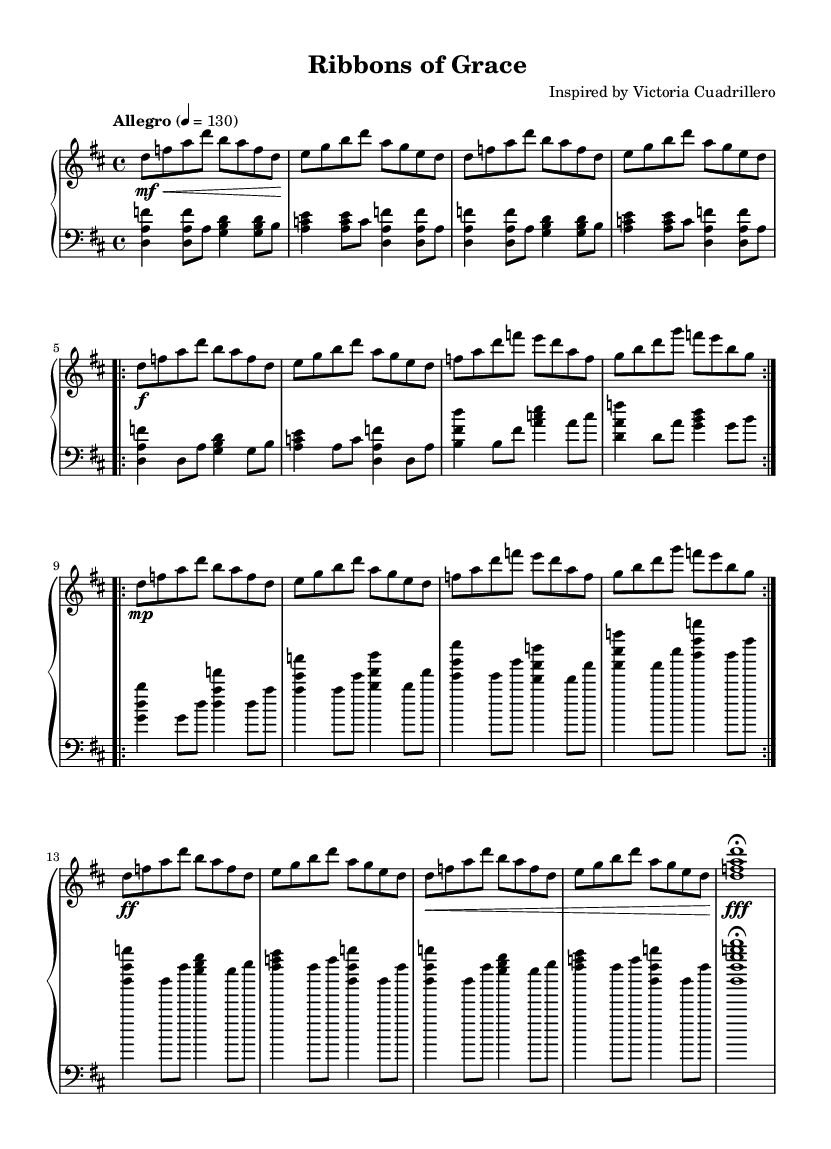What is the key signature of this music? The key signature can be determined by identifying the sharps or flats indicated at the beginning of the piece. In this case, there are two sharps, F# and C#, which corresponds to the D major key signature.
Answer: D major What is the time signature of this music? The time signature is located at the beginning of the sheet music, which shows the division of beats in each measure. Here, the notation "4/4" indicates that there are four beats per measure, and the quarter note is one beat.
Answer: 4/4 What is the tempo marking of the piece? The tempo is indicated by the instruction "Allegro" followed by a metronome marking of 4 = 130. This suggests a fast pace, typically around 120-168 beats per minute.
Answer: Allegro, 130 What is the musical form of this piece? By analyzing the structure of the piece, we see distinct sections labeled as Section A, Section B, and a Coda. The repetition of Section A and B also suggests a binary form overall.
Answer: ABA' Coda How many times is Section A repeated? The score indicates a "repeat volta 2" for Section A, meaning that it is performed twice as shown in the markings.
Answer: 2 What does "mp" indicate in the music? The marking "mp" stands for "mezzo-piano", which directs the musician to play moderately softly. This is a dynamic marking found before Section B in the score.
Answer: Mezzo-piano What does the fermata symbol indicate in the score? The fermata symbol is a sign placed over a note to instruct the musician to hold that note longer than its usual duration, generally at the player's discretion. In this piece, it appears at the end of the Coda.
Answer: Hold the note 